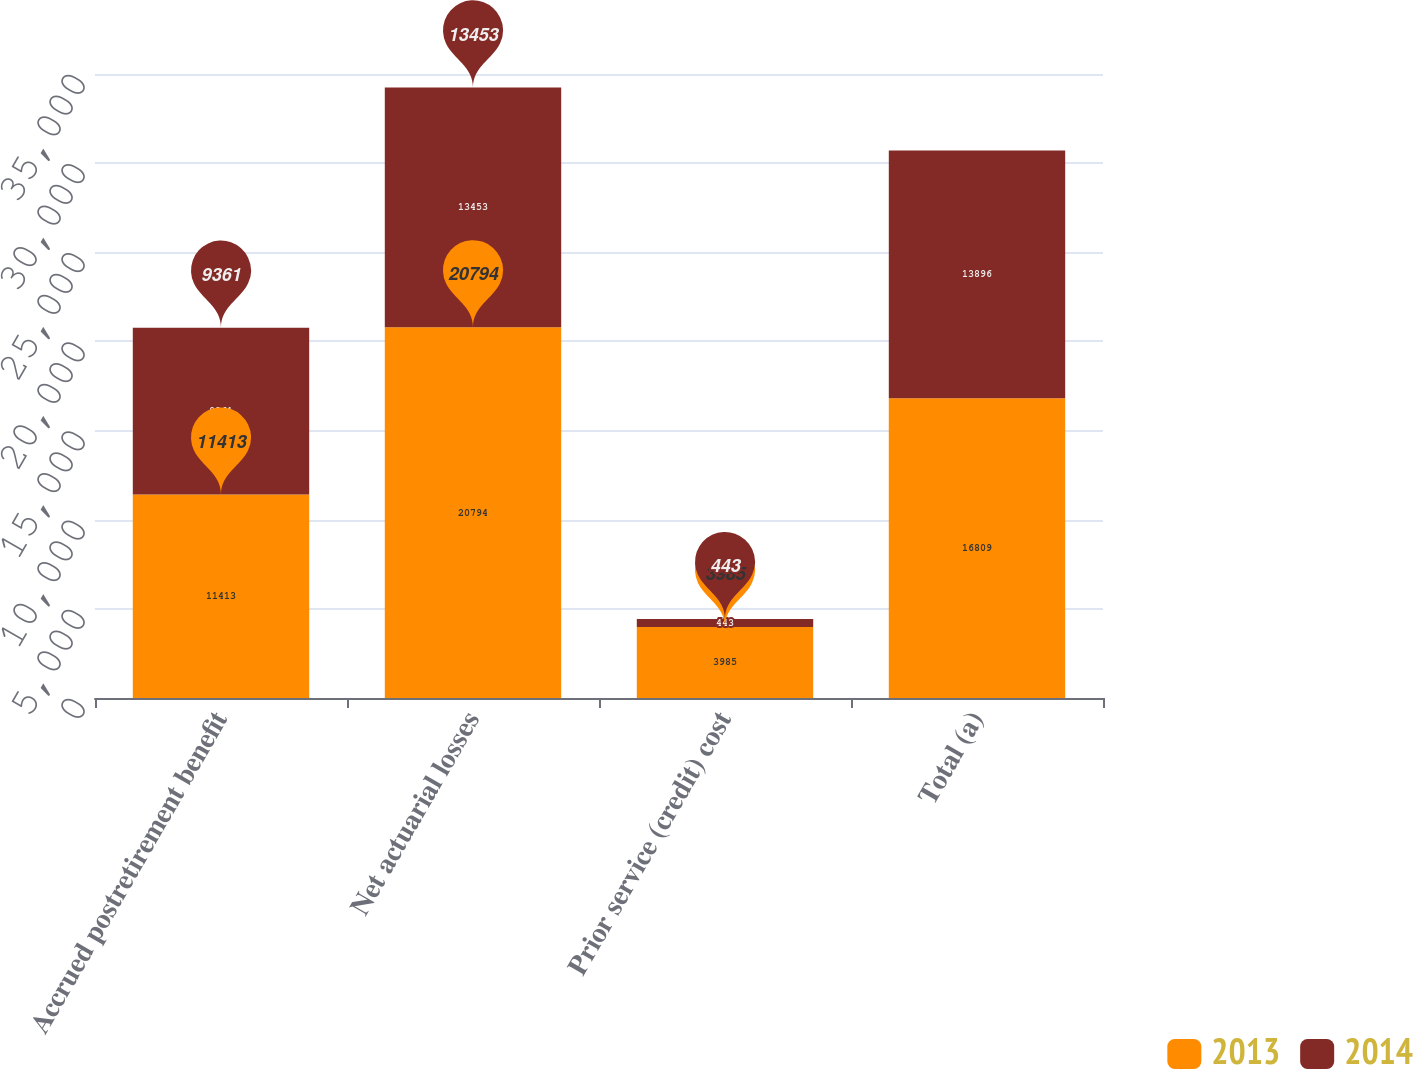Convert chart to OTSL. <chart><loc_0><loc_0><loc_500><loc_500><stacked_bar_chart><ecel><fcel>Accrued postretirement benefit<fcel>Net actuarial losses<fcel>Prior service (credit) cost<fcel>Total (a)<nl><fcel>2013<fcel>11413<fcel>20794<fcel>3985<fcel>16809<nl><fcel>2014<fcel>9361<fcel>13453<fcel>443<fcel>13896<nl></chart> 